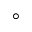<formula> <loc_0><loc_0><loc_500><loc_500>^ { \circ }</formula> 